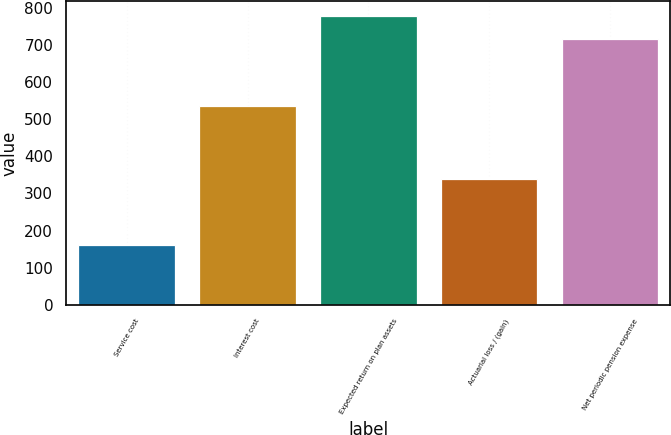Convert chart. <chart><loc_0><loc_0><loc_500><loc_500><bar_chart><fcel>Service cost<fcel>Interest cost<fcel>Expected return on plan assets<fcel>Actuarial loss / (gain)<fcel>Net periodic pension expense<nl><fcel>160<fcel>536<fcel>778.4<fcel>339<fcel>717<nl></chart> 